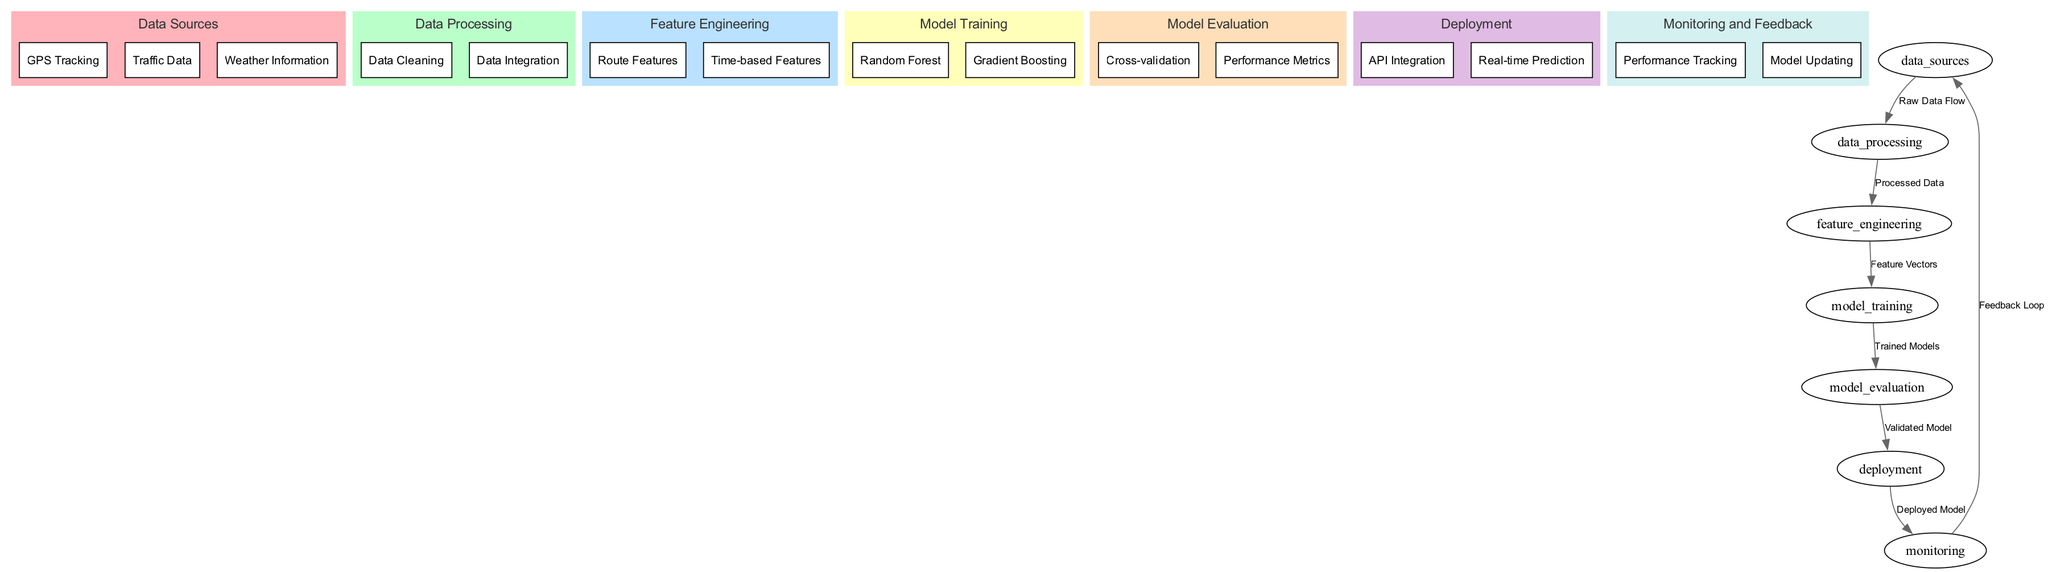What are the three data sources? The diagram lists three data sources: GPS Tracking, Traffic Data, and Weather Information under the "Data Sources" node.
Answer: GPS Tracking, Traffic Data, Weather Information How many nodes are in the diagram? The diagram contains six main nodes: Data Sources, Data Processing, Feature Engineering, Model Training, Model Evaluation, Deployment, and Monitoring.
Answer: Six What does the edge from "Model Evaluation" to "Deployment" represent? This edge indicates the flow of a validated model from the Model Evaluation stage to the Deployment stage, essential for making predictions in real-world scenarios.
Answer: Validated Model Which model training methods are included? The diagram indicates two model training methods, Random Forest and Gradient Boosting, under the "Model Training" node.
Answer: Random Forest, Gradient Boosting What is the purpose of the edge connecting "Monitoring" to "Data Sources"? This edge displays the feedback loop from Monitoring to Data Sources, illustrating how performance tracking can provide feedback to improve the data collection process.
Answer: Feedback Loop What is the main goal of the "Feature Engineering" phase? The Feature Engineering phase aims to extract relevant features (Route Features and Time-based Features) from processed data to be utilized for model training, improving the model's predictive performance.
Answer: Extract relevant features What happens after "Model Training"? After the Model Training phase, the trained models are passed to the Model Evaluation phase for performance assessment and validation before deployment.
Answer: Go to Model Evaluation Which node follows the "Deployment" node? The node that follows Deployment is Monitoring, which tracks the performance and provides feedback on the deployed model's effectiveness.
Answer: Monitoring How are performance metrics evaluated? Performance metrics are evaluated during the Model Evaluation phase through methods such as cross-validation, ensuring that the models perform well on unseen data.
Answer: Cross-validation, Performance Metrics 